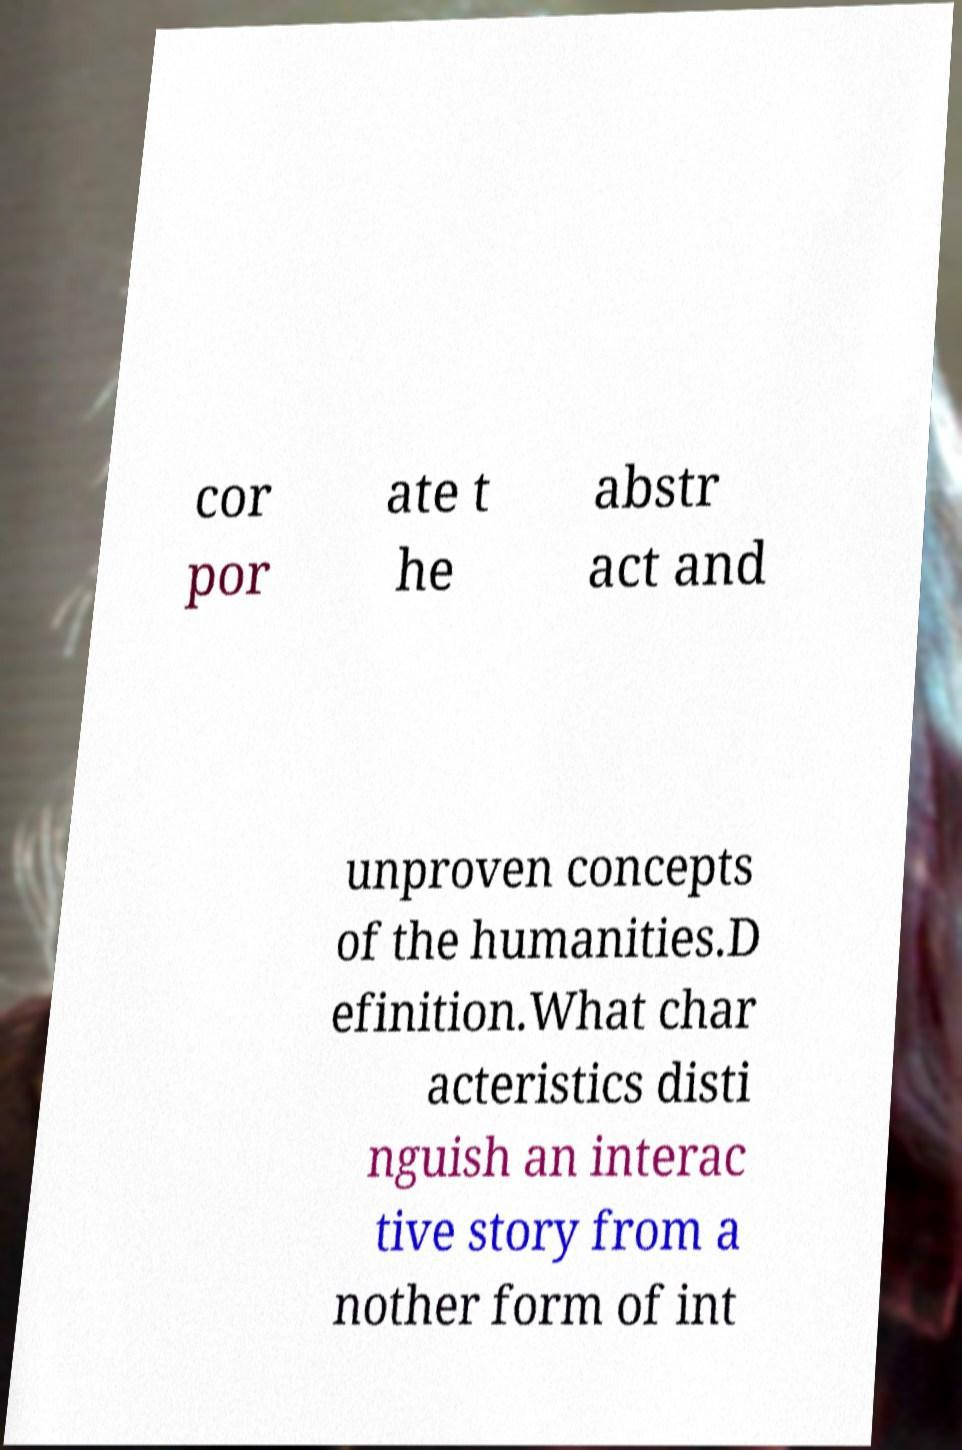Please identify and transcribe the text found in this image. cor por ate t he abstr act and unproven concepts of the humanities.D efinition.What char acteristics disti nguish an interac tive story from a nother form of int 